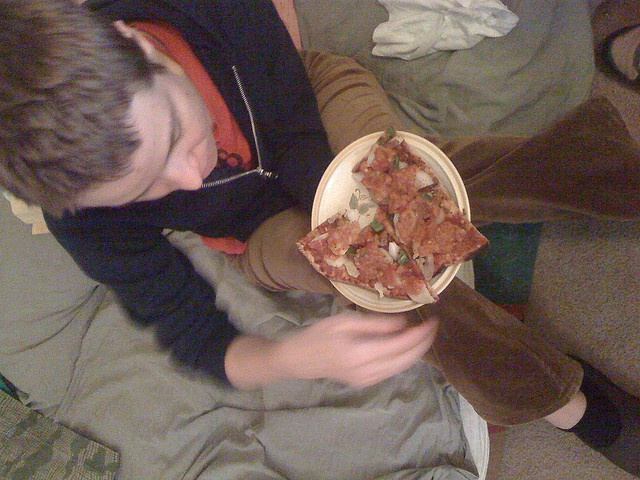Describe the objects in this image and their specific colors. I can see people in purple, black, maroon, and gray tones, bed in purple and gray tones, and pizza in purple, brown, and tan tones in this image. 